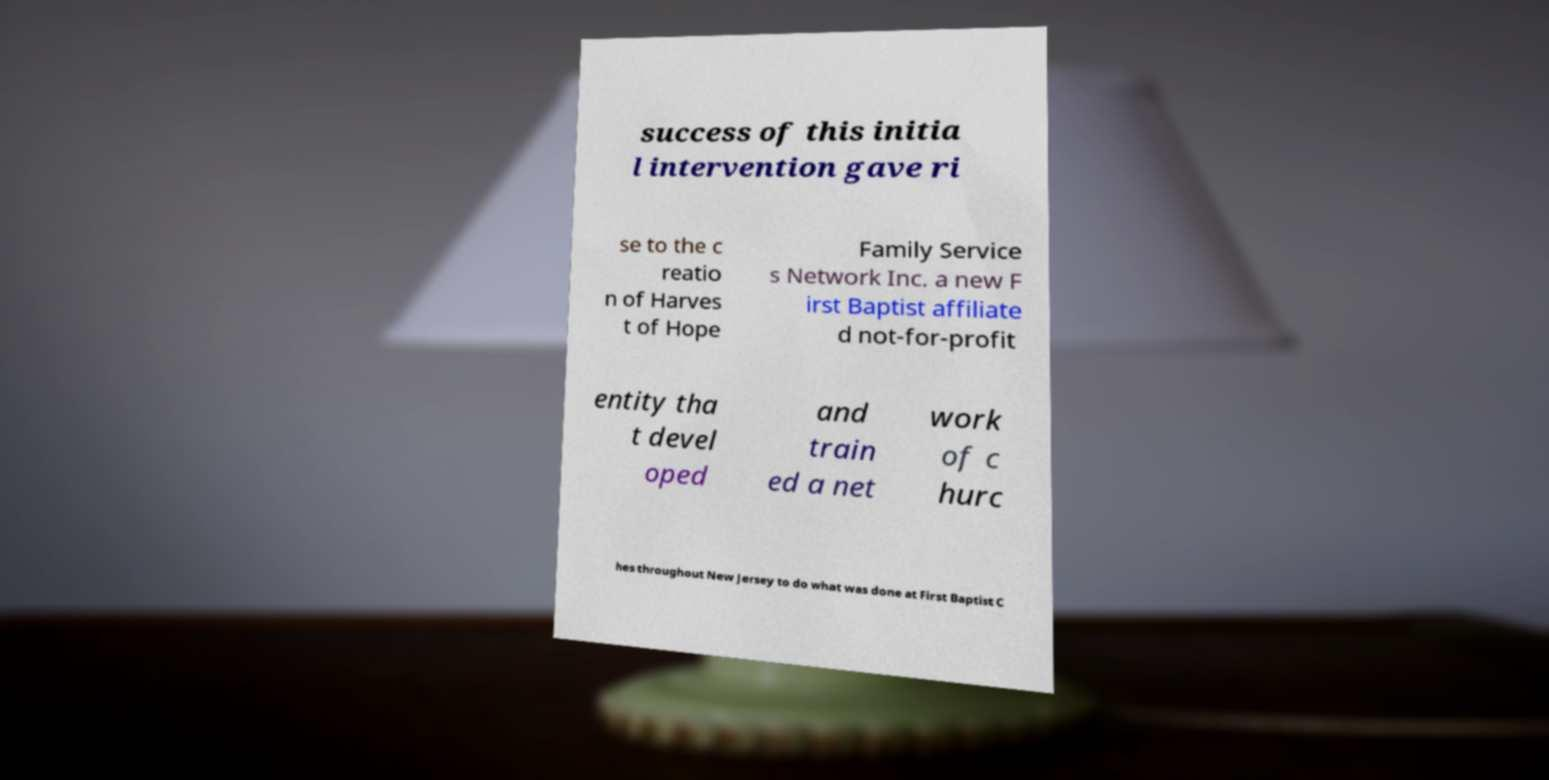Can you read and provide the text displayed in the image?This photo seems to have some interesting text. Can you extract and type it out for me? success of this initia l intervention gave ri se to the c reatio n of Harves t of Hope Family Service s Network Inc. a new F irst Baptist affiliate d not-for-profit entity tha t devel oped and train ed a net work of c hurc hes throughout New Jersey to do what was done at First Baptist C 